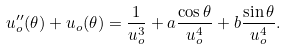Convert formula to latex. <formula><loc_0><loc_0><loc_500><loc_500>u _ { o } ^ { \prime \prime } ( \theta ) + u _ { o } ( \theta ) = \frac { 1 } { u _ { o } ^ { 3 } } + a \frac { \cos \theta } { u _ { o } ^ { 4 } } + b \frac { \sin \theta } { u _ { o } ^ { 4 } } .</formula> 